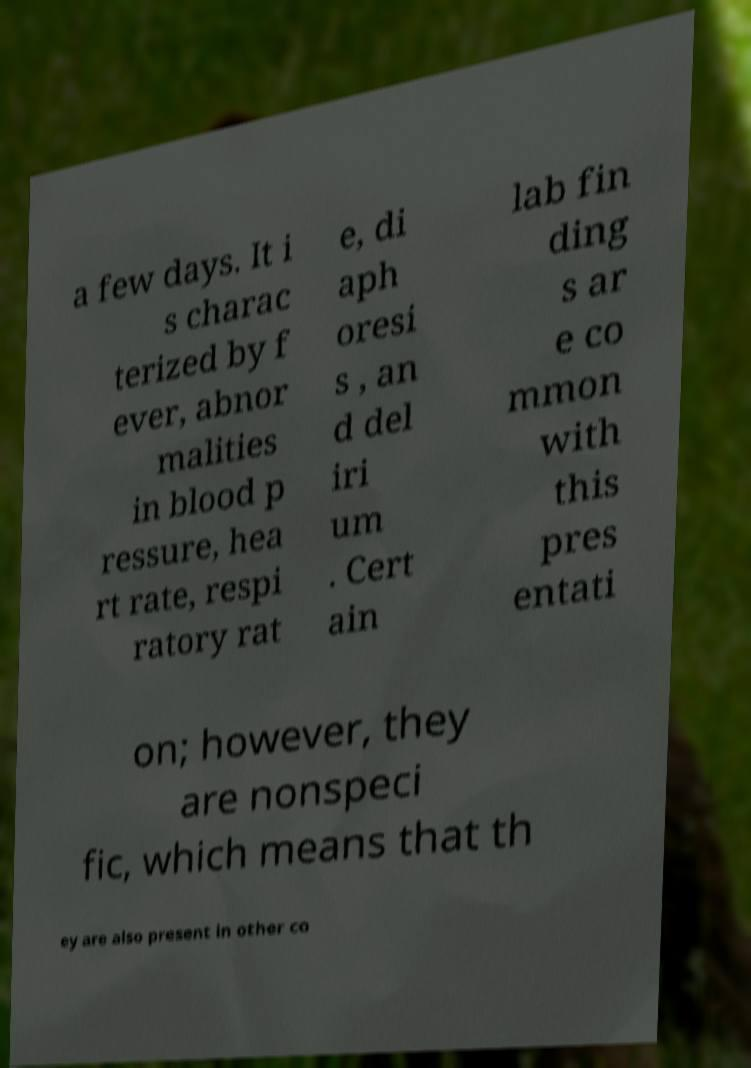Please read and relay the text visible in this image. What does it say? a few days. It i s charac terized by f ever, abnor malities in blood p ressure, hea rt rate, respi ratory rat e, di aph oresi s , an d del iri um . Cert ain lab fin ding s ar e co mmon with this pres entati on; however, they are nonspeci fic, which means that th ey are also present in other co 